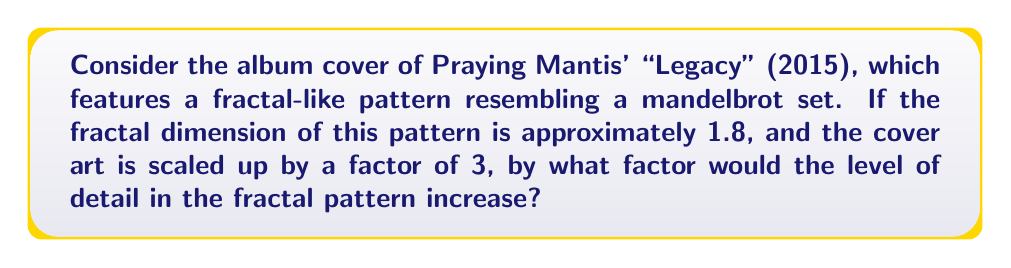Solve this math problem. To solve this problem, we need to understand the relationship between fractal dimension, scaling factor, and level of detail. Let's approach this step-by-step:

1) The fractal dimension (D) is given as 1.8.

2) The scaling factor (r) is 3.

3) For fractals, the relationship between the number of self-similar pieces (N) and the scaling factor (r) is given by the equation:

   $$N = r^D$$

4) In our case, we want to find how many times more detailed the pattern becomes. This is equivalent to finding N:

   $$N = 3^{1.8}$$

5) Let's calculate this:

   $$N = 3^{1.8} \approx 5.196$$

6) This means that when we scale up the album cover by a factor of 3, the level of detail in the fractal pattern increases by a factor of approximately 5.196.

Therefore, the level of detail in the fractal pattern would increase by a factor of about 5.2.
Answer: 5.2 